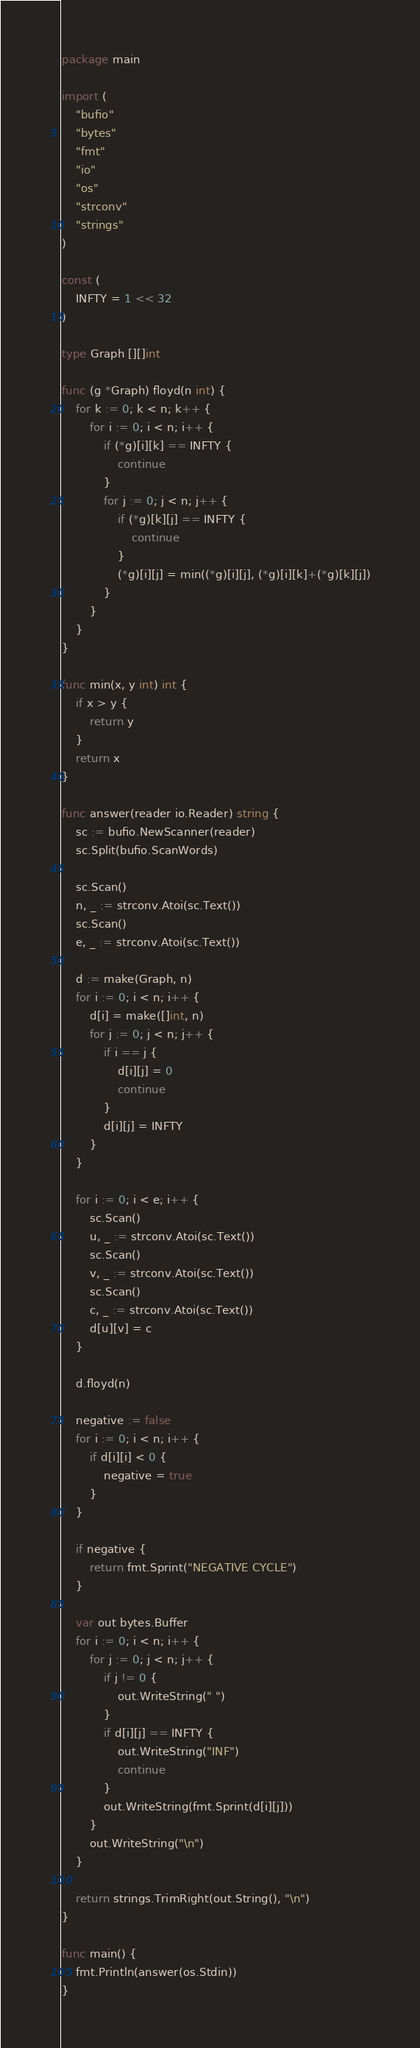<code> <loc_0><loc_0><loc_500><loc_500><_Go_>package main

import (
	"bufio"
	"bytes"
	"fmt"
	"io"
	"os"
	"strconv"
	"strings"
)

const (
	INFTY = 1 << 32
)

type Graph [][]int

func (g *Graph) floyd(n int) {
	for k := 0; k < n; k++ {
		for i := 0; i < n; i++ {
			if (*g)[i][k] == INFTY {
				continue
			}
			for j := 0; j < n; j++ {
				if (*g)[k][j] == INFTY {
					continue
				}
				(*g)[i][j] = min((*g)[i][j], (*g)[i][k]+(*g)[k][j])
			}
		}
	}
}

func min(x, y int) int {
	if x > y {
		return y
	}
	return x
}

func answer(reader io.Reader) string {
	sc := bufio.NewScanner(reader)
	sc.Split(bufio.ScanWords)

	sc.Scan()
	n, _ := strconv.Atoi(sc.Text())
	sc.Scan()
	e, _ := strconv.Atoi(sc.Text())

	d := make(Graph, n)
	for i := 0; i < n; i++ {
		d[i] = make([]int, n)
		for j := 0; j < n; j++ {
			if i == j {
				d[i][j] = 0
				continue
			}
			d[i][j] = INFTY
		}
	}

	for i := 0; i < e; i++ {
		sc.Scan()
		u, _ := strconv.Atoi(sc.Text())
		sc.Scan()
		v, _ := strconv.Atoi(sc.Text())
		sc.Scan()
		c, _ := strconv.Atoi(sc.Text())
		d[u][v] = c
	}

	d.floyd(n)

	negative := false
	for i := 0; i < n; i++ {
		if d[i][i] < 0 {
			negative = true
		}
	}

	if negative {
		return fmt.Sprint("NEGATIVE CYCLE")
	}

	var out bytes.Buffer
	for i := 0; i < n; i++ {
		for j := 0; j < n; j++ {
			if j != 0 {
				out.WriteString(" ")
			}
			if d[i][j] == INFTY {
				out.WriteString("INF")
				continue
			}
			out.WriteString(fmt.Sprint(d[i][j]))
		}
		out.WriteString("\n")
	}

	return strings.TrimRight(out.String(), "\n")
}

func main() {
	fmt.Println(answer(os.Stdin))
}

</code> 